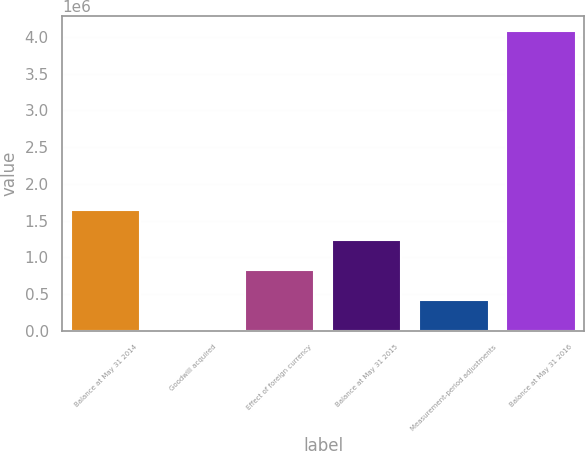<chart> <loc_0><loc_0><loc_500><loc_500><bar_chart><fcel>Balance at May 31 2014<fcel>Goodwill acquired<fcel>Effect of foreign currency<fcel>Balance at May 31 2015<fcel>Measurement-period adjustments<fcel>Balance at May 31 2016<nl><fcel>1.63745e+06<fcel>4794<fcel>821121<fcel>1.22928e+06<fcel>412958<fcel>4.08643e+06<nl></chart> 